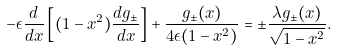<formula> <loc_0><loc_0><loc_500><loc_500>- \epsilon \frac { d } { d x } \left [ ( 1 - x ^ { 2 } ) \frac { d g _ { \pm } } { d x } \right ] + \frac { g _ { \pm } ( x ) } { 4 \epsilon ( 1 - x ^ { 2 } ) } = \pm \frac { \lambda g _ { \pm } ( x ) } { \sqrt { 1 - x ^ { 2 } } } .</formula> 